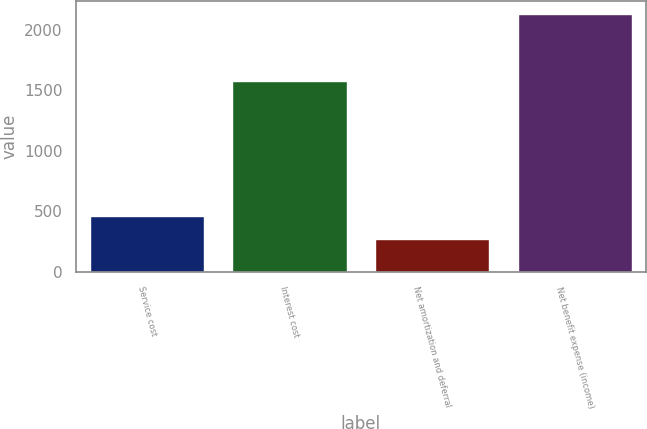Convert chart. <chart><loc_0><loc_0><loc_500><loc_500><bar_chart><fcel>Service cost<fcel>Interest cost<fcel>Net amortization and deferral<fcel>Net benefit expense (income)<nl><fcel>460.6<fcel>1577<fcel>275<fcel>2131<nl></chart> 